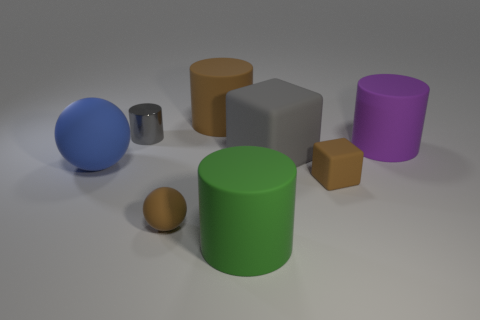What number of rubber things are tiny gray objects or brown things?
Offer a very short reply. 3. What is the size of the rubber object that is to the left of the matte ball that is in front of the big blue thing?
Keep it short and to the point. Large. There is a cube that is the same color as the shiny object; what is it made of?
Your answer should be compact. Rubber. Is there a cylinder to the right of the cylinder to the right of the cube behind the blue matte thing?
Keep it short and to the point. No. Do the brown thing that is behind the large ball and the gray thing that is in front of the small shiny thing have the same material?
Your answer should be very brief. Yes. How many things are large purple matte cylinders or cylinders that are behind the big green matte cylinder?
Make the answer very short. 3. What number of tiny rubber objects have the same shape as the large gray rubber thing?
Provide a short and direct response. 1. There is a purple object that is the same size as the gray rubber cube; what material is it?
Keep it short and to the point. Rubber. There is a rubber cylinder in front of the gray thing on the right side of the small thing behind the blue rubber ball; what size is it?
Your answer should be very brief. Large. Do the big rubber cylinder that is in front of the big gray cube and the matte cube on the right side of the gray rubber block have the same color?
Provide a succinct answer. No. 